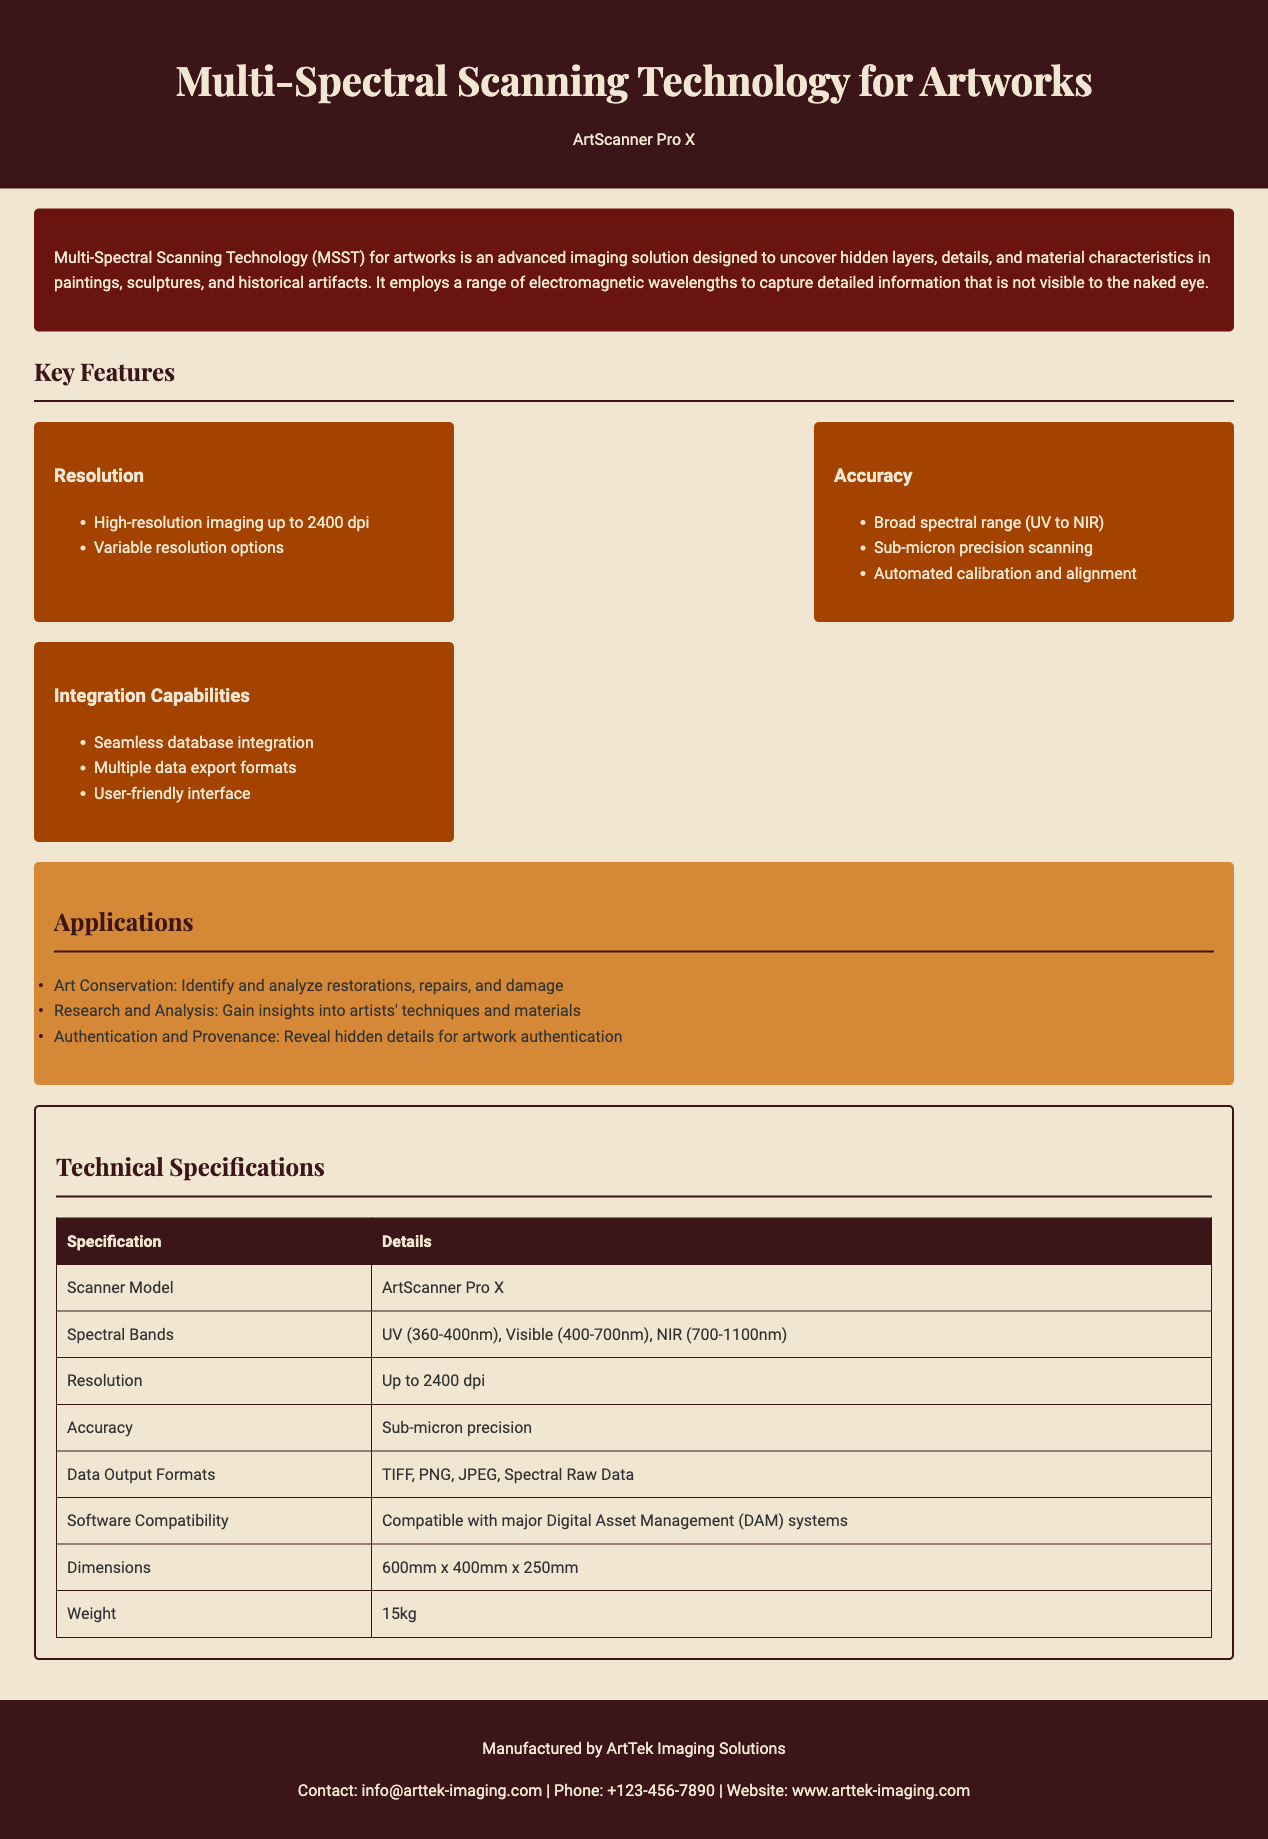What is the maximum resolution offered by the scanner? The document specifies that the maximum resolution is "up to 2400 dpi."
Answer: 2400 dpi What spectral bands does the scanner utilize? The document lists the spectral bands as "UV (360-400nm), Visible (400-700nm), NIR (700-1100nm)."
Answer: UV, Visible, NIR What type of precision does the scanning technology achieve? According to the document, the scanner achieves "Sub-micron precision."
Answer: Sub-micron What are the data output formats supported by the scanner? The document states the supported formats include "TIFF, PNG, JPEG, Spectral Raw Data."
Answer: TIFF, PNG, JPEG, Spectral Raw Data What is the scanner model mentioned in the specifications? The document specifies the model as "ArtScanner Pro X."
Answer: ArtScanner Pro X How many key features are listed in the document? The document outlines three key features: Resolution, Accuracy, and Integration Capabilities.
Answer: Three What is the weight of the scanning device? The specifications indicate that the weight is "15kg."
Answer: 15kg Which company manufactures the scanning technology? The footer of the document states that it is manufactured by "ArtTek Imaging Solutions."
Answer: ArtTek Imaging Solutions What type of applications can this technology assist with? The applications listed in the document include art conservation, research and analysis, and authentication and provenance.
Answer: Art conservation, research and analysis, authentication and provenance 